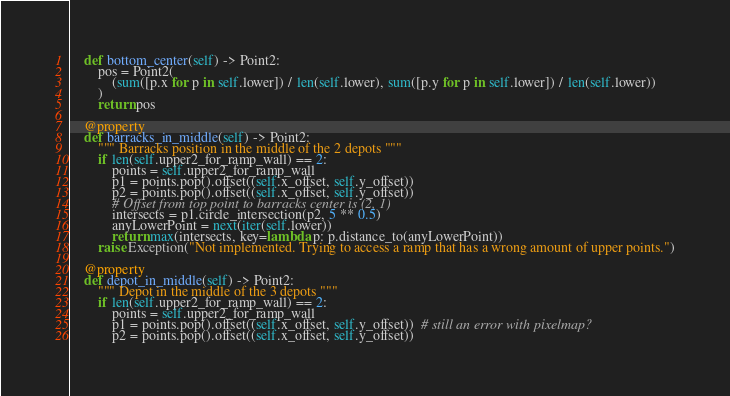<code> <loc_0><loc_0><loc_500><loc_500><_Python_>    def bottom_center(self) -> Point2:
        pos = Point2(
            (sum([p.x for p in self.lower]) / len(self.lower), sum([p.y for p in self.lower]) / len(self.lower))
        )
        return pos

    @property
    def barracks_in_middle(self) -> Point2:
        """ Barracks position in the middle of the 2 depots """
        if len(self.upper2_for_ramp_wall) == 2:
            points = self.upper2_for_ramp_wall
            p1 = points.pop().offset((self.x_offset, self.y_offset))
            p2 = points.pop().offset((self.x_offset, self.y_offset))
            # Offset from top point to barracks center is (2, 1)
            intersects = p1.circle_intersection(p2, 5 ** 0.5)
            anyLowerPoint = next(iter(self.lower))
            return max(intersects, key=lambda p: p.distance_to(anyLowerPoint))
        raise Exception("Not implemented. Trying to access a ramp that has a wrong amount of upper points.")

    @property
    def depot_in_middle(self) -> Point2:
        """ Depot in the middle of the 3 depots """
        if len(self.upper2_for_ramp_wall) == 2:
            points = self.upper2_for_ramp_wall
            p1 = points.pop().offset((self.x_offset, self.y_offset))  # still an error with pixelmap?
            p2 = points.pop().offset((self.x_offset, self.y_offset))</code> 